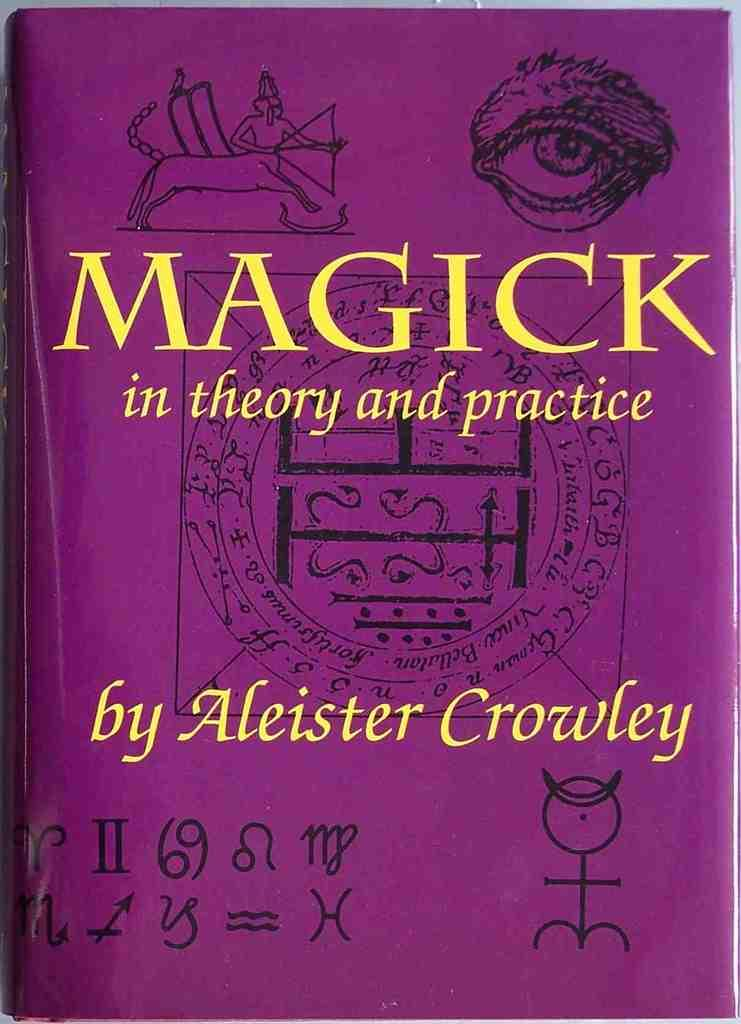<image>
Create a compact narrative representing the image presented. A person named Aleister Crowley has written a book about magic. 